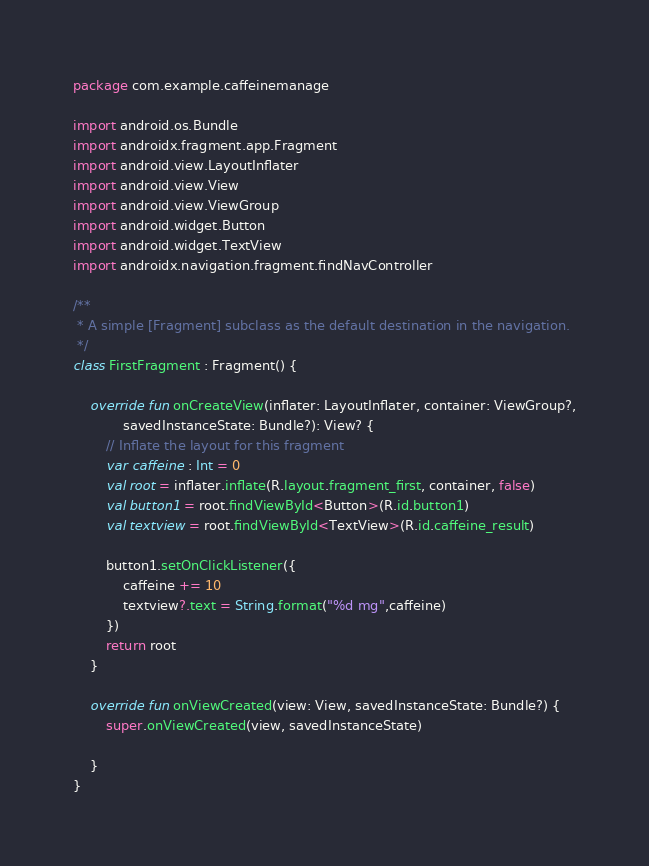<code> <loc_0><loc_0><loc_500><loc_500><_Kotlin_>package com.example.caffeinemanage

import android.os.Bundle
import androidx.fragment.app.Fragment
import android.view.LayoutInflater
import android.view.View
import android.view.ViewGroup
import android.widget.Button
import android.widget.TextView
import androidx.navigation.fragment.findNavController

/**
 * A simple [Fragment] subclass as the default destination in the navigation.
 */
class FirstFragment : Fragment() {

    override fun onCreateView(inflater: LayoutInflater, container: ViewGroup?,
            savedInstanceState: Bundle?): View? {
        // Inflate the layout for this fragment
        var caffeine : Int = 0
        val root = inflater.inflate(R.layout.fragment_first, container, false)
        val button1 = root.findViewById<Button>(R.id.button1)
        val textview = root.findViewById<TextView>(R.id.caffeine_result)

        button1.setOnClickListener({
            caffeine += 10
            textview?.text = String.format("%d mg",caffeine)
        })
        return root
    }

    override fun onViewCreated(view: View, savedInstanceState: Bundle?) {
        super.onViewCreated(view, savedInstanceState)

    }
}</code> 